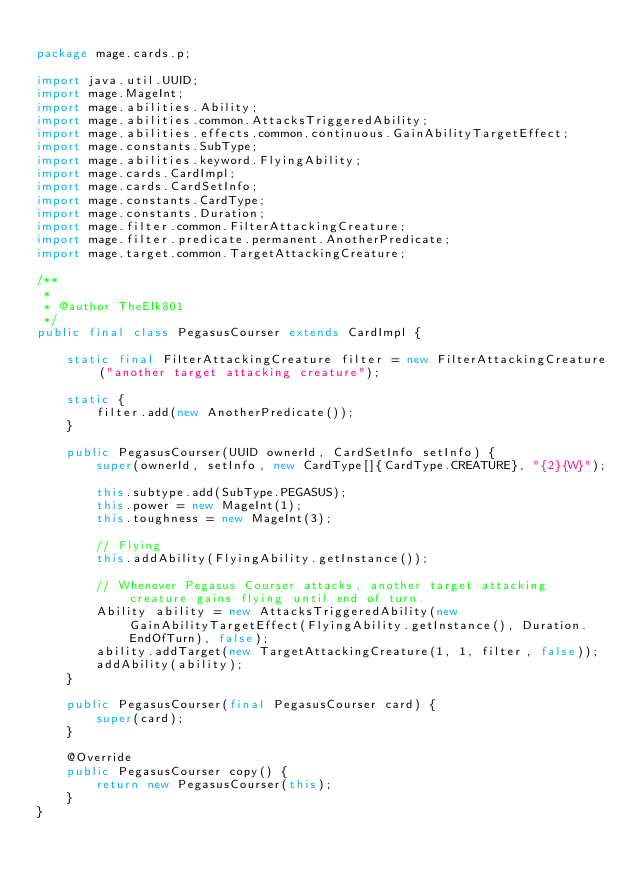Convert code to text. <code><loc_0><loc_0><loc_500><loc_500><_Java_>
package mage.cards.p;

import java.util.UUID;
import mage.MageInt;
import mage.abilities.Ability;
import mage.abilities.common.AttacksTriggeredAbility;
import mage.abilities.effects.common.continuous.GainAbilityTargetEffect;
import mage.constants.SubType;
import mage.abilities.keyword.FlyingAbility;
import mage.cards.CardImpl;
import mage.cards.CardSetInfo;
import mage.constants.CardType;
import mage.constants.Duration;
import mage.filter.common.FilterAttackingCreature;
import mage.filter.predicate.permanent.AnotherPredicate;
import mage.target.common.TargetAttackingCreature;

/**
 *
 * @author TheElk801
 */
public final class PegasusCourser extends CardImpl {

    static final FilterAttackingCreature filter = new FilterAttackingCreature("another target attacking creature");

    static {
        filter.add(new AnotherPredicate());
    }

    public PegasusCourser(UUID ownerId, CardSetInfo setInfo) {
        super(ownerId, setInfo, new CardType[]{CardType.CREATURE}, "{2}{W}");

        this.subtype.add(SubType.PEGASUS);
        this.power = new MageInt(1);
        this.toughness = new MageInt(3);

        // Flying
        this.addAbility(FlyingAbility.getInstance());

        // Whenever Pegasus Courser attacks, another target attacking creature gains flying until end of turn.
        Ability ability = new AttacksTriggeredAbility(new GainAbilityTargetEffect(FlyingAbility.getInstance(), Duration.EndOfTurn), false);
        ability.addTarget(new TargetAttackingCreature(1, 1, filter, false));
        addAbility(ability);
    }

    public PegasusCourser(final PegasusCourser card) {
        super(card);
    }

    @Override
    public PegasusCourser copy() {
        return new PegasusCourser(this);
    }
}
</code> 